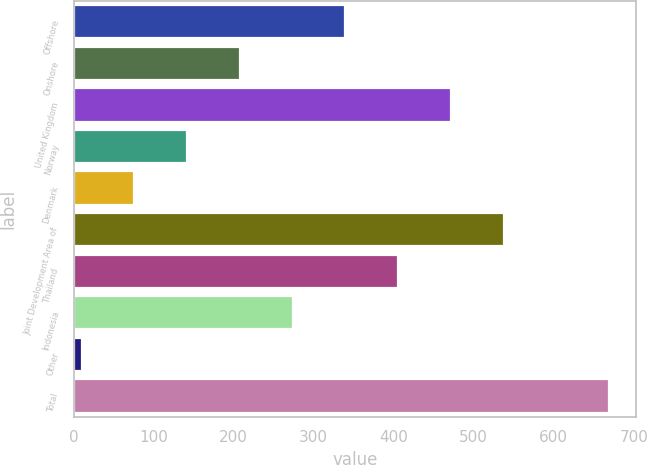<chart> <loc_0><loc_0><loc_500><loc_500><bar_chart><fcel>Offshore<fcel>Onshore<fcel>United Kingdom<fcel>Norway<fcel>Denmark<fcel>Joint Development Area of<fcel>Thailand<fcel>Indonesia<fcel>Other<fcel>Total<nl><fcel>339.5<fcel>207.7<fcel>471.3<fcel>141.8<fcel>75.9<fcel>537.2<fcel>405.4<fcel>273.6<fcel>10<fcel>669<nl></chart> 